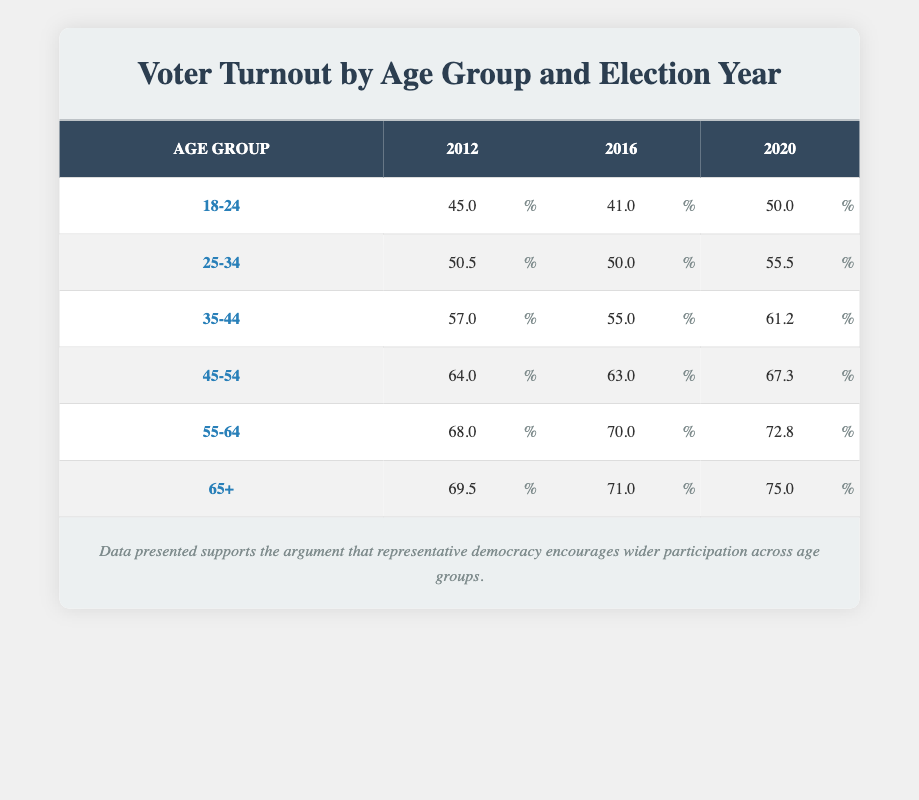What was the voter turnout percentage for the age group 35-44 in 2020? From the table, the turnout percentage for the age group 35-44 in 2020 is indicated in the relevant row under the 2020 column. That value is 61.2.
Answer: 61.2 Which age group had the highest voter turnout in 2016? By checking the 2016 column for each age group, the highest turnout percentage can be found in the age group 65+, which has a turnout of 71.0.
Answer: 65+ What is the difference in voter turnout between the age groups 45-54 and 55-64 for 2012? The turnout percentage for the age group 45-54 in 2012 is 64.0, and for the 55-64 age group, it is 68.0. To find the difference, subtract 64.0 from 68.0: 68.0 - 64.0 = 4.0.
Answer: 4.0 Did the voter turnout for the age group 18-24 increase from 2016 to 2020? The turnout for the age group 18-24 in 2016 is 41.0, while in 2020 it is 50.0. Since 50.0 is greater than 41.0, we can confirm that there was an increase.
Answer: Yes What was the overall voter turnout trend for voters aged 65+ from 2012 to 2020? The 2012 voter turnout for the 65+ age group is 69.5, in 2016 it is 71.0, and in 2020 it is 75.0. The turnout has increased each election year: 69.5 to 71.0 (an increase of 1.5) and 71.0 to 75.0 (an increase of 4.0), indicating a positive trend over the years.
Answer: Increasing What is the average voter turnout percentage for the age group 25-34 across all three election years? The turnout percentages for the 25-34 age group are 50.5 in 2012, 50.0 in 2016, and 55.5 in 2020. To find the average, sum these values: 50.5 + 50.0 + 55.5 = 156.0, and then divide by 3 (the number of entries): 156.0 / 3 = 52.0.
Answer: 52.0 Which age group had a voter turnout of exactly 70% or higher in 2020? The age groups and their corresponding percentages in 2020 must be checked. The age groups 55-64 (72.8) and 65+ (75.0) meet this criterion, confirming that these were the groups with turnout percentages at or above 70%.
Answer: 55-64 and 65+ What is the pattern of voter turnout for the age group 18-24 over the three election years? The turnout percentages for 18-24 are 45.0 in 2012, 41.0 in 2016, and 50.0 in 2020. This indicates a decline from 2012 to 2016, followed by an increase from 2016 to 2020, suggesting variability in engagement among younger voters.
Answer: Decline, then increase 